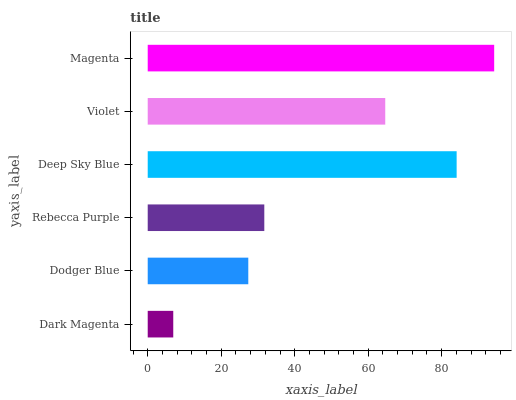Is Dark Magenta the minimum?
Answer yes or no. Yes. Is Magenta the maximum?
Answer yes or no. Yes. Is Dodger Blue the minimum?
Answer yes or no. No. Is Dodger Blue the maximum?
Answer yes or no. No. Is Dodger Blue greater than Dark Magenta?
Answer yes or no. Yes. Is Dark Magenta less than Dodger Blue?
Answer yes or no. Yes. Is Dark Magenta greater than Dodger Blue?
Answer yes or no. No. Is Dodger Blue less than Dark Magenta?
Answer yes or no. No. Is Violet the high median?
Answer yes or no. Yes. Is Rebecca Purple the low median?
Answer yes or no. Yes. Is Deep Sky Blue the high median?
Answer yes or no. No. Is Violet the low median?
Answer yes or no. No. 